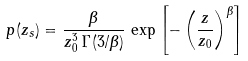Convert formula to latex. <formula><loc_0><loc_0><loc_500><loc_500>p ( z _ { s } ) = \frac { \beta } { z _ { 0 } ^ { 3 } \, \Gamma ( 3 / \beta ) } \, \exp \left [ - \left ( \frac { z } { z _ { 0 } } \right ) ^ { \beta } \right ]</formula> 